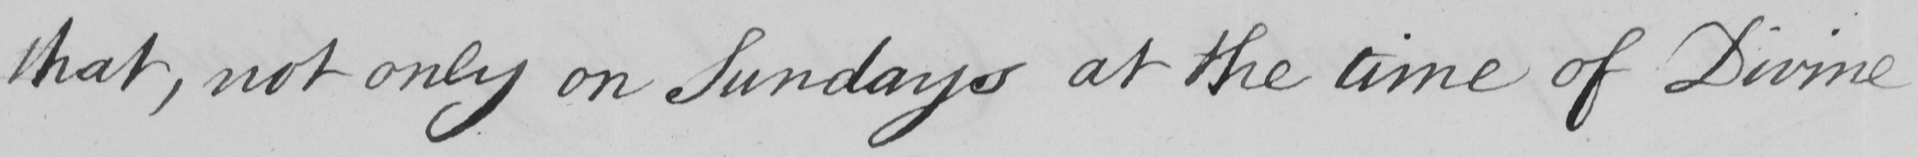Can you tell me what this handwritten text says? that not only on Sundays at the time of Divine 